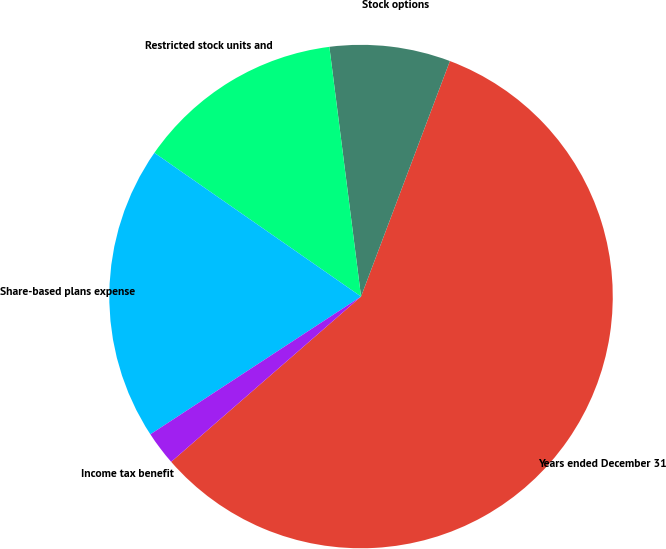Convert chart. <chart><loc_0><loc_0><loc_500><loc_500><pie_chart><fcel>Years ended December 31<fcel>Stock options<fcel>Restricted stock units and<fcel>Share-based plans expense<fcel>Income tax benefit<nl><fcel>57.86%<fcel>7.75%<fcel>13.32%<fcel>18.89%<fcel>2.18%<nl></chart> 